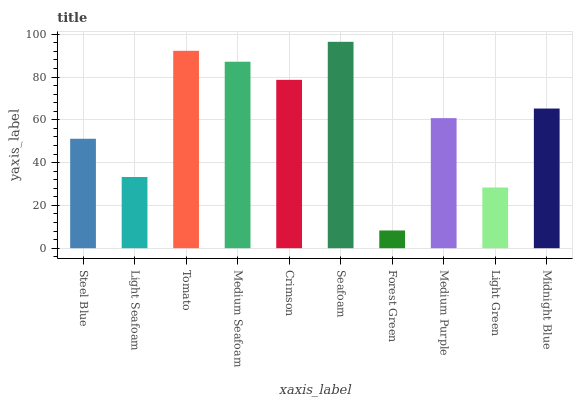Is Forest Green the minimum?
Answer yes or no. Yes. Is Seafoam the maximum?
Answer yes or no. Yes. Is Light Seafoam the minimum?
Answer yes or no. No. Is Light Seafoam the maximum?
Answer yes or no. No. Is Steel Blue greater than Light Seafoam?
Answer yes or no. Yes. Is Light Seafoam less than Steel Blue?
Answer yes or no. Yes. Is Light Seafoam greater than Steel Blue?
Answer yes or no. No. Is Steel Blue less than Light Seafoam?
Answer yes or no. No. Is Midnight Blue the high median?
Answer yes or no. Yes. Is Medium Purple the low median?
Answer yes or no. Yes. Is Seafoam the high median?
Answer yes or no. No. Is Steel Blue the low median?
Answer yes or no. No. 